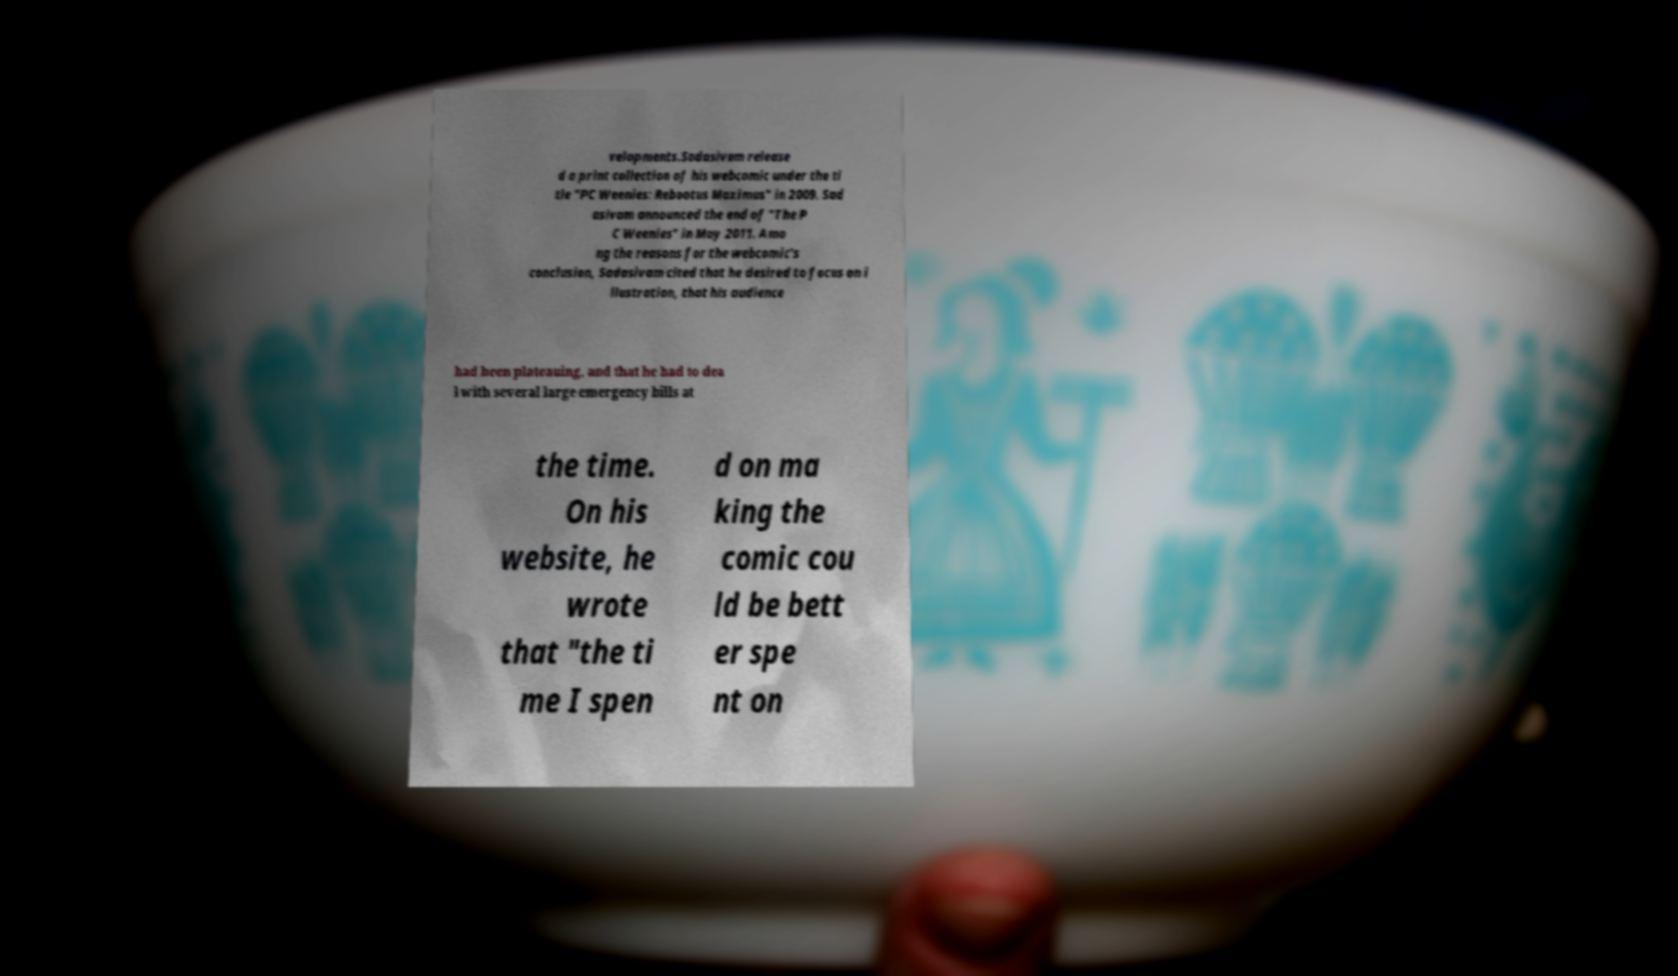Can you accurately transcribe the text from the provided image for me? velopments.Sadasivam release d a print collection of his webcomic under the ti tle "PC Weenies: Rebootus Maximus" in 2009. Sad asivam announced the end of "The P C Weenies" in May 2011. Amo ng the reasons for the webcomic's conclusion, Sadasivam cited that he desired to focus on i llustration, that his audience had been plateauing, and that he had to dea l with several large emergency bills at the time. On his website, he wrote that "the ti me I spen d on ma king the comic cou ld be bett er spe nt on 